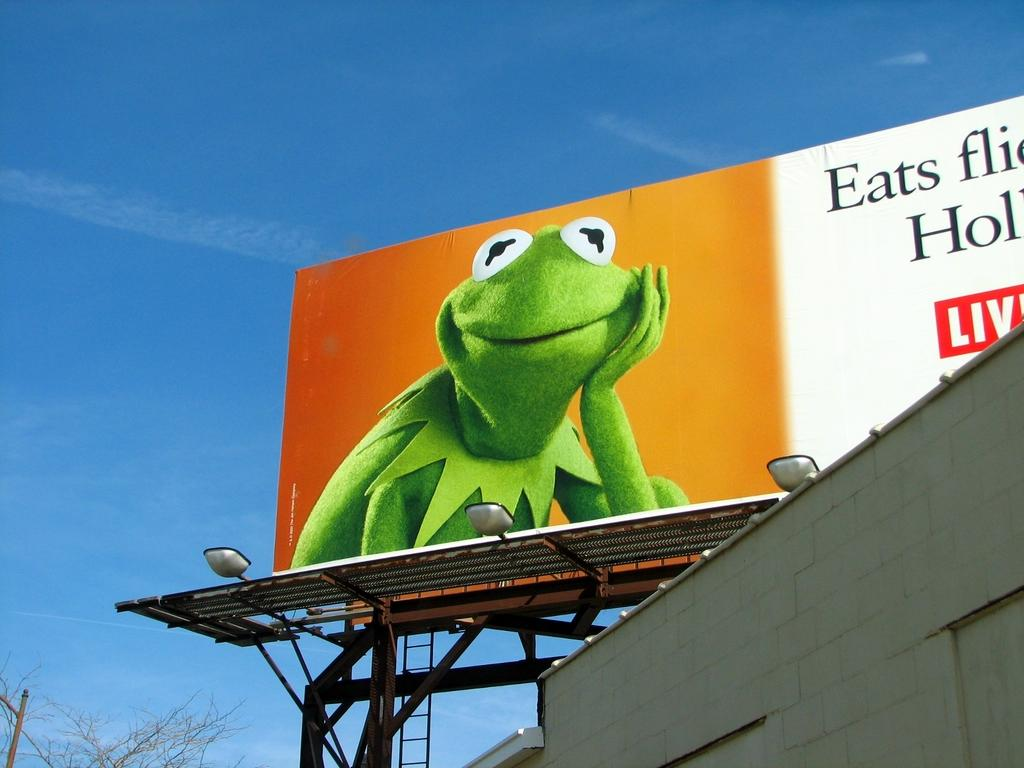What is the main subject in the foreground of the image? There is a building in the foreground of the image. What other objects can be seen in the foreground of the image? Lights, metal rods, trees, and a hoarding are present in the foreground of the image. What is the color of the sky in the background of the image? The sky is blue in the background of the image. Can you tell me anything about the time of day when the image was taken? The image was likely taken during the day, as the sky is blue and there are no visible light sources other than the ones in the foreground. What flavor of light can be seen emanating from the lights in the image? There is no such thing as a flavor of light; light does not have a taste. The lights in the image are simply illuminating the scene. Are there any bats visible in the image? No, there are no bats present in the image. 